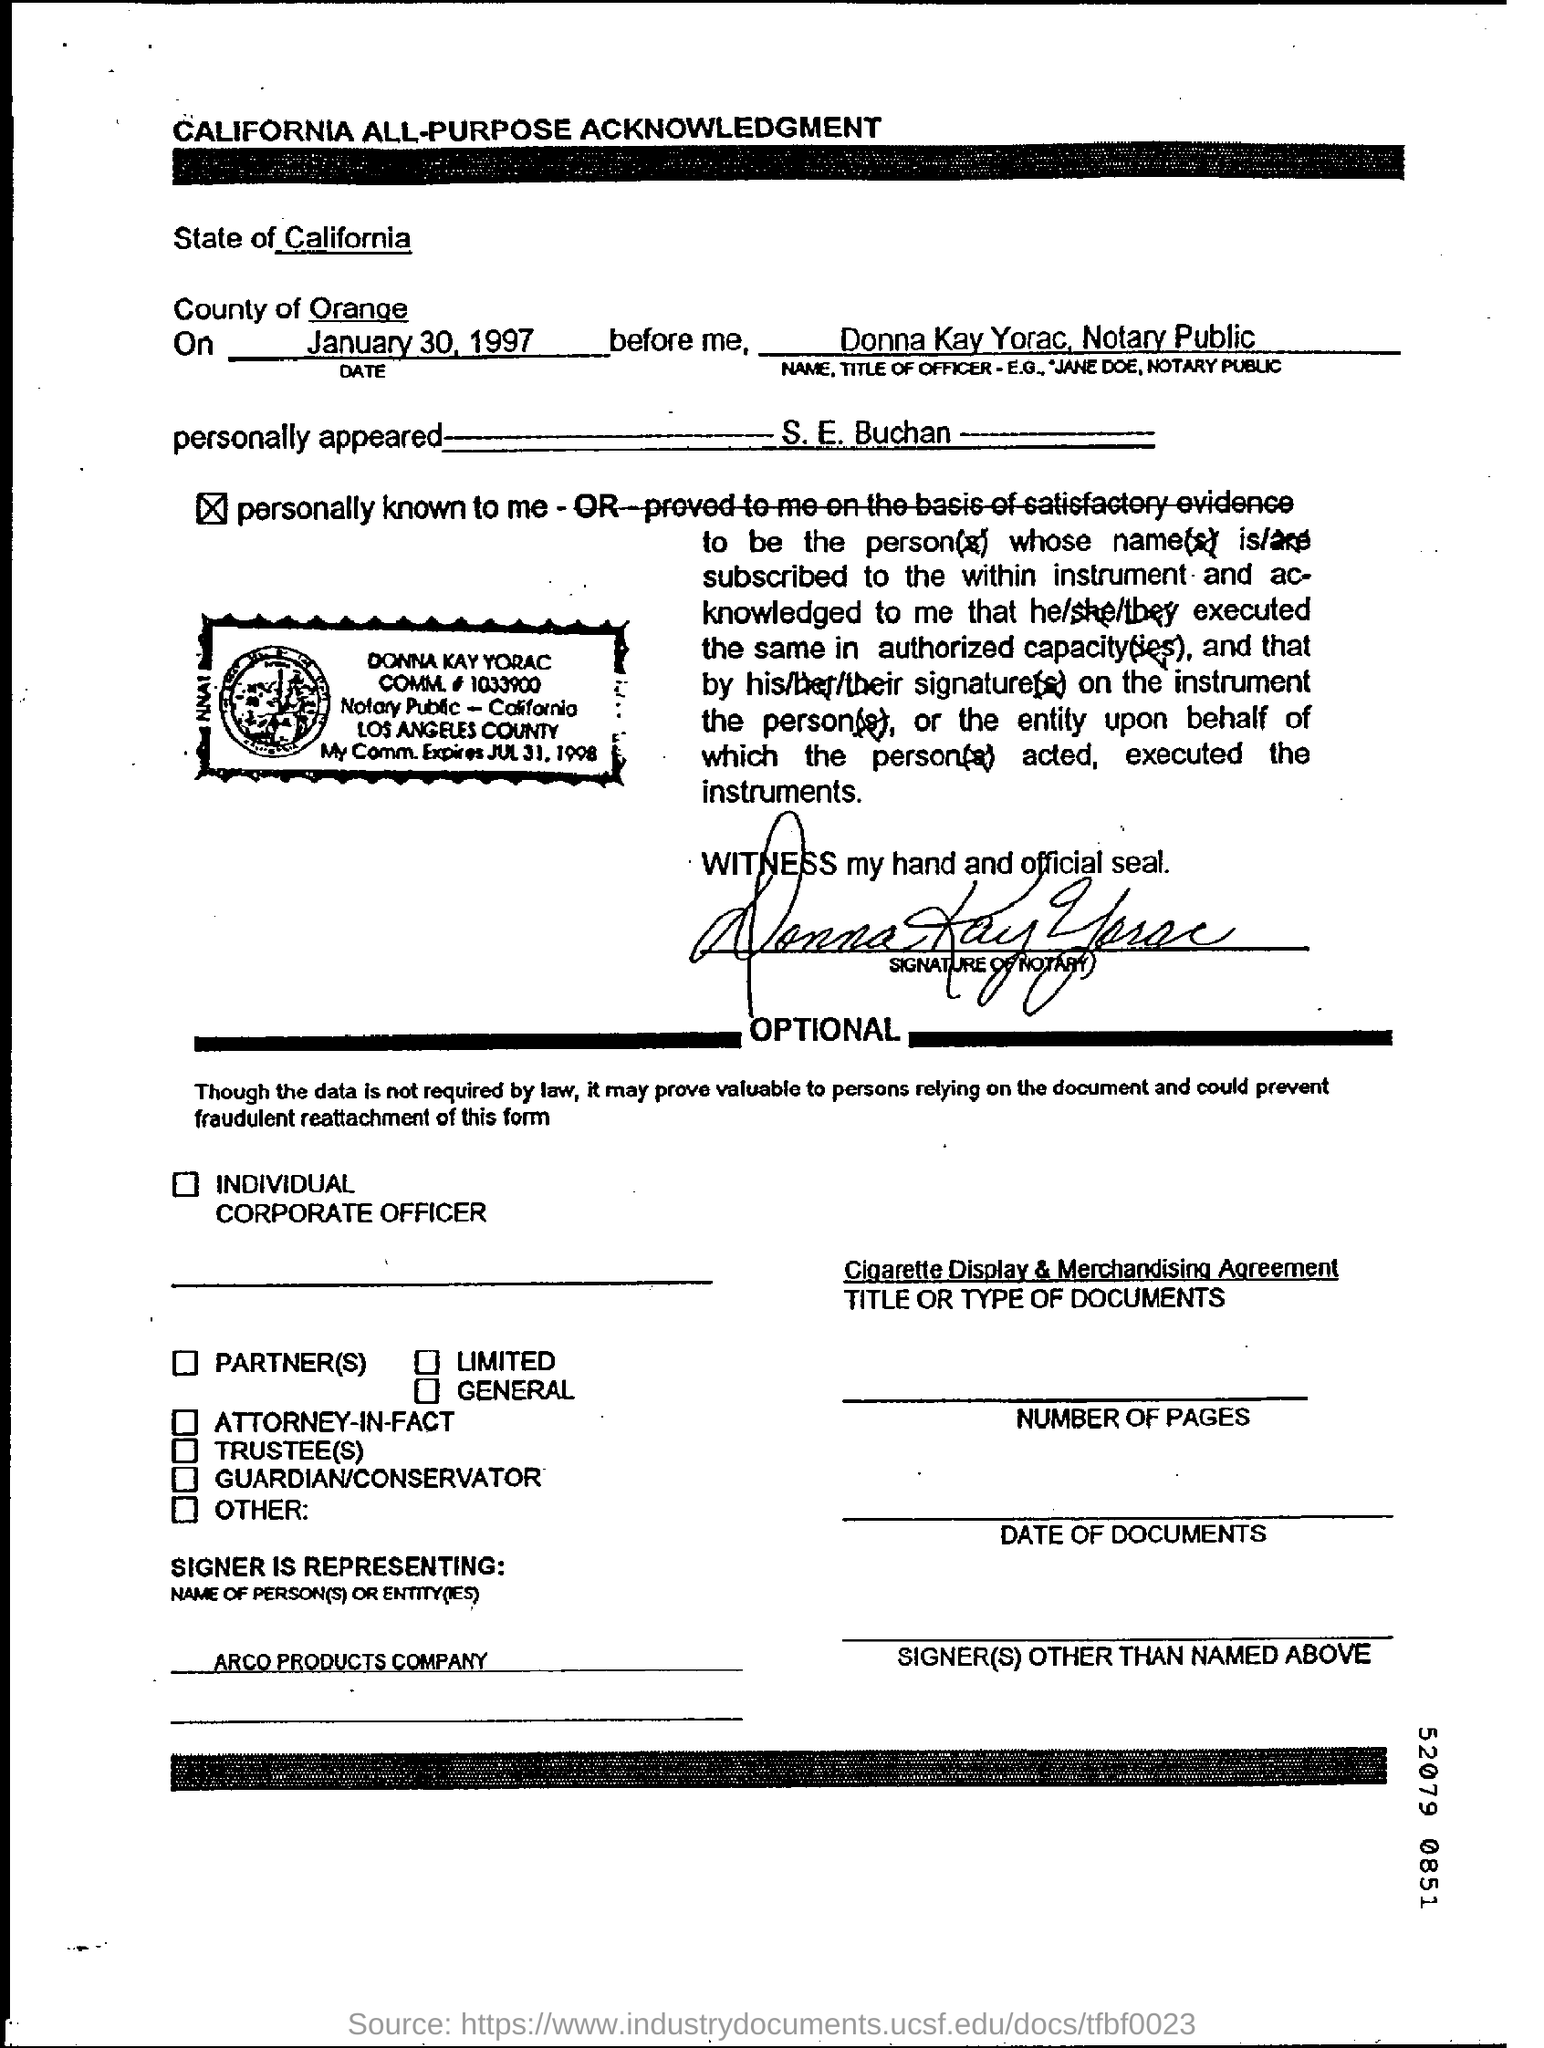Outline some significant characteristics in this image. The California All-Purpose Acknowledgment is written in the letterhead. The date at the top of the document is January 30, 1997. 